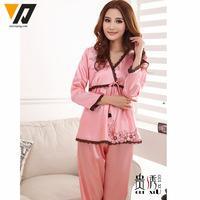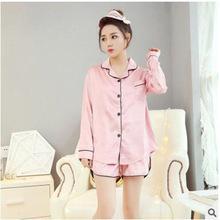The first image is the image on the left, the second image is the image on the right. Examine the images to the left and right. Is the description "there is a woman in long sleeved pink pajamas in front of a window with window blinds" accurate? Answer yes or no. Yes. The first image is the image on the left, the second image is the image on the right. Assess this claim about the two images: "The combined images include three models in short gowns in pinkish pastel shades, one wearing a matching robe over the gown.". Correct or not? Answer yes or no. No. 